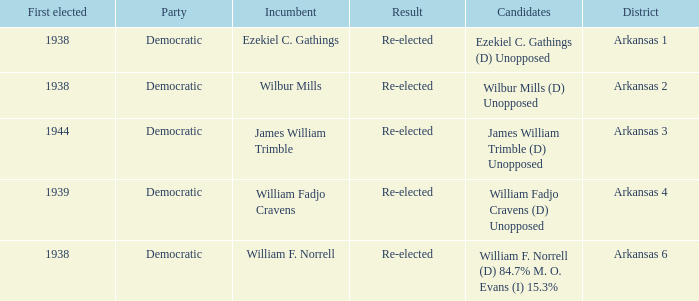Which party has a first elected number bigger than 1939.0? Democratic. Give me the full table as a dictionary. {'header': ['First elected', 'Party', 'Incumbent', 'Result', 'Candidates', 'District'], 'rows': [['1938', 'Democratic', 'Ezekiel C. Gathings', 'Re-elected', 'Ezekiel C. Gathings (D) Unopposed', 'Arkansas 1'], ['1938', 'Democratic', 'Wilbur Mills', 'Re-elected', 'Wilbur Mills (D) Unopposed', 'Arkansas 2'], ['1944', 'Democratic', 'James William Trimble', 'Re-elected', 'James William Trimble (D) Unopposed', 'Arkansas 3'], ['1939', 'Democratic', 'William Fadjo Cravens', 'Re-elected', 'William Fadjo Cravens (D) Unopposed', 'Arkansas 4'], ['1938', 'Democratic', 'William F. Norrell', 'Re-elected', 'William F. Norrell (D) 84.7% M. O. Evans (I) 15.3%', 'Arkansas 6']]} 